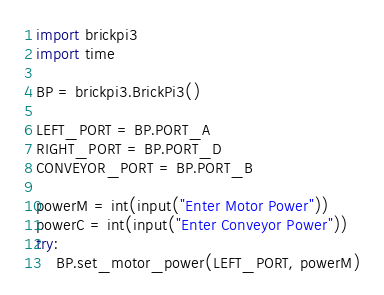Convert code to text. <code><loc_0><loc_0><loc_500><loc_500><_Python_>import brickpi3
import time

BP = brickpi3.BrickPi3()

LEFT_PORT = BP.PORT_A
RIGHT_PORT = BP.PORT_D
CONVEYOR_PORT = BP.PORT_B

powerM = int(input("Enter Motor Power"))
powerC = int(input("Enter Conveyor Power"))
try:
    BP.set_motor_power(LEFT_PORT, powerM)</code> 